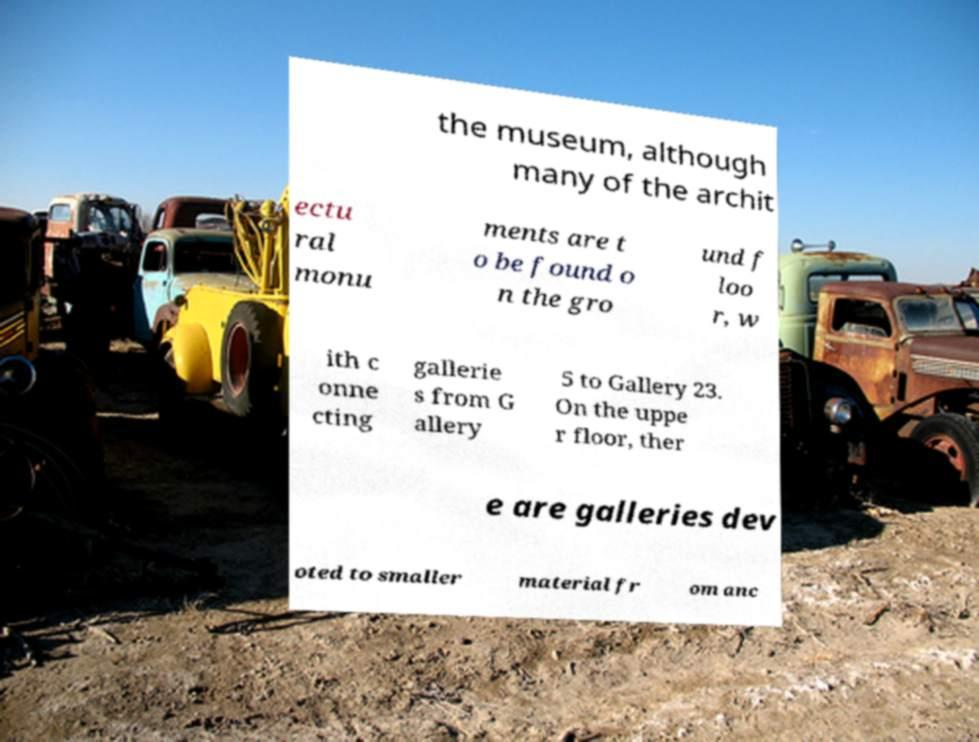Could you assist in decoding the text presented in this image and type it out clearly? the museum, although many of the archit ectu ral monu ments are t o be found o n the gro und f loo r, w ith c onne cting gallerie s from G allery 5 to Gallery 23. On the uppe r floor, ther e are galleries dev oted to smaller material fr om anc 